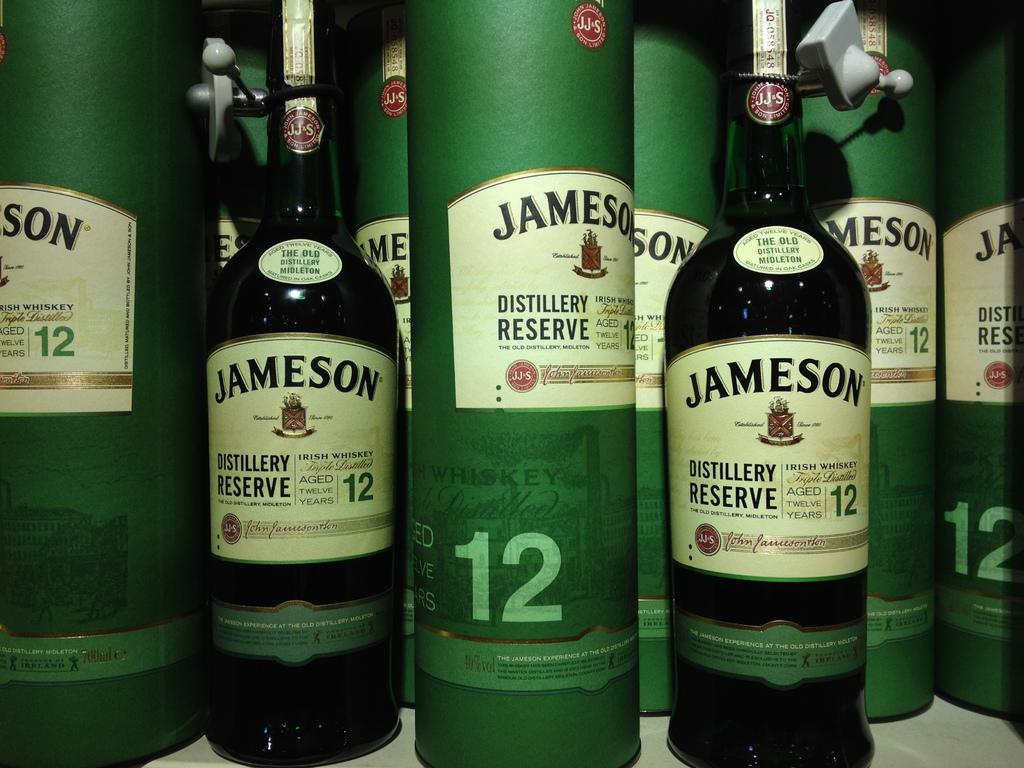Provide a one-sentence caption for the provided image. Many bottles of Jameson are showcased with the number 12 on the label. 